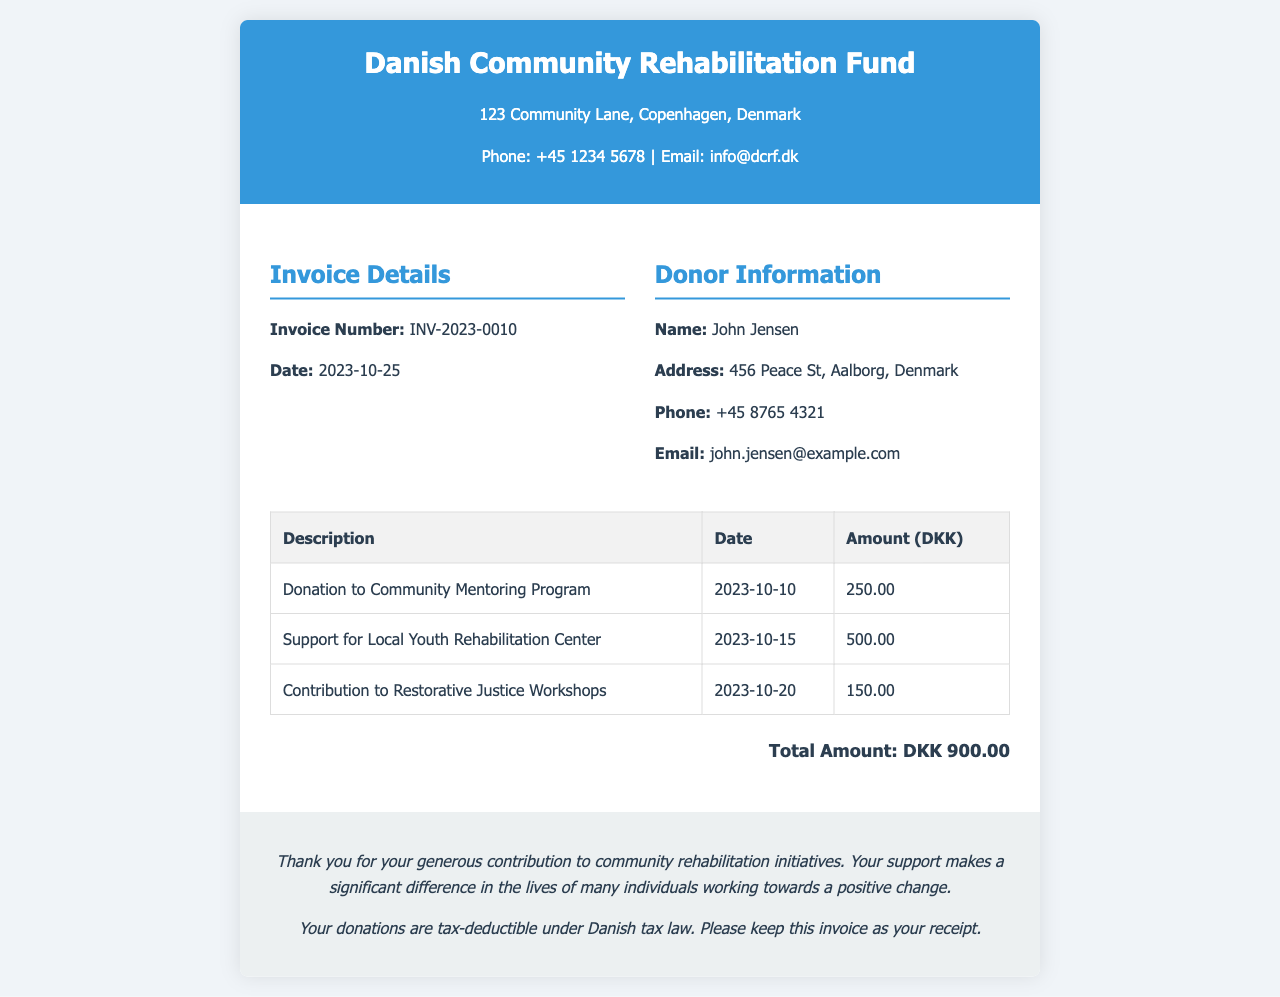What is the invoice number? The invoice number is listed under the invoice details section.
Answer: INV-2023-0010 What is the total amount of the donations? The total amount is stated at the end of the invoice in the total section.
Answer: DKK 900.00 What date was the donation made to the Community Mentoring Program? The donation date is provided in the table for that specific donation.
Answer: 2023-10-10 Who is the donor? The donor's name is listed in the donor information section of the invoice.
Answer: John Jensen What donation supports local youth rehabilitation? The description of the donation mentions the specific support for local youth.
Answer: Support for Local Youth Rehabilitation Center What is the purpose of the invoice? The purpose of the invoice is indicated in the footer section regarding community rehabilitation initiatives.
Answer: Donations for community rehabilitation initiatives How many donations are listed in the invoice? The number of items in the donations table indicates the total donations made.
Answer: 3 Is the donation tax-deductible? This information is mentioned in the footer of the document.
Answer: Yes 